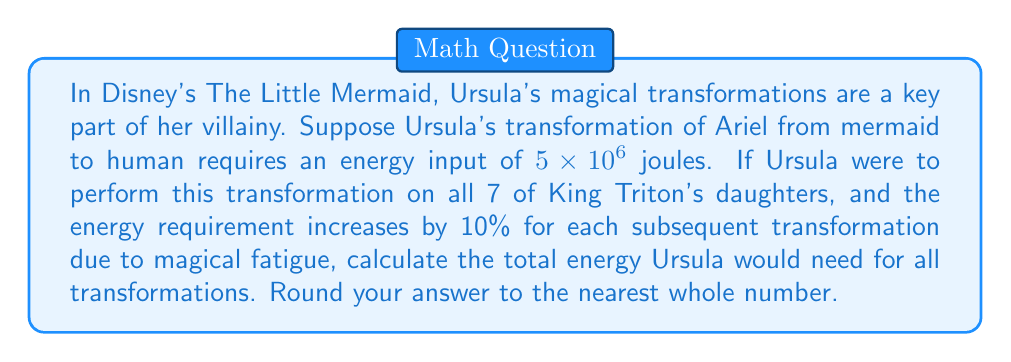Provide a solution to this math problem. Let's approach this step-by-step:

1) First, we need to calculate the energy required for each transformation:

   1st transformation (Ariel): $5 \times 10^6$ J
   2nd transformation: $5 \times 10^6 \times 1.1 = 5.5 \times 10^6$ J
   3rd transformation: $5.5 \times 10^6 \times 1.1 = 6.05 \times 10^6$ J
   4th transformation: $6.05 \times 10^6 \times 1.1 = 6.655 \times 10^6$ J
   5th transformation: $6.655 \times 10^6 \times 1.1 = 7.3205 \times 10^6$ J
   6th transformation: $7.3205 \times 10^6 \times 1.1 = 8.05255 \times 10^6$ J
   7th transformation: $8.05255 \times 10^6 \times 1.1 = 8.857805 \times 10^6$ J

2) Now, we sum up all these energies:

   $$E_{total} = 5 + 5.5 + 6.05 + 6.655 + 7.3205 + 8.05255 + 8.857805$$
   $$E_{total} = 47.435855 \times 10^6 \text{ J}$$

3) Rounding to the nearest whole number:

   $$E_{total} \approx 47 \times 10^6 \text{ J}$$
Answer: $47 \times 10^6$ J 